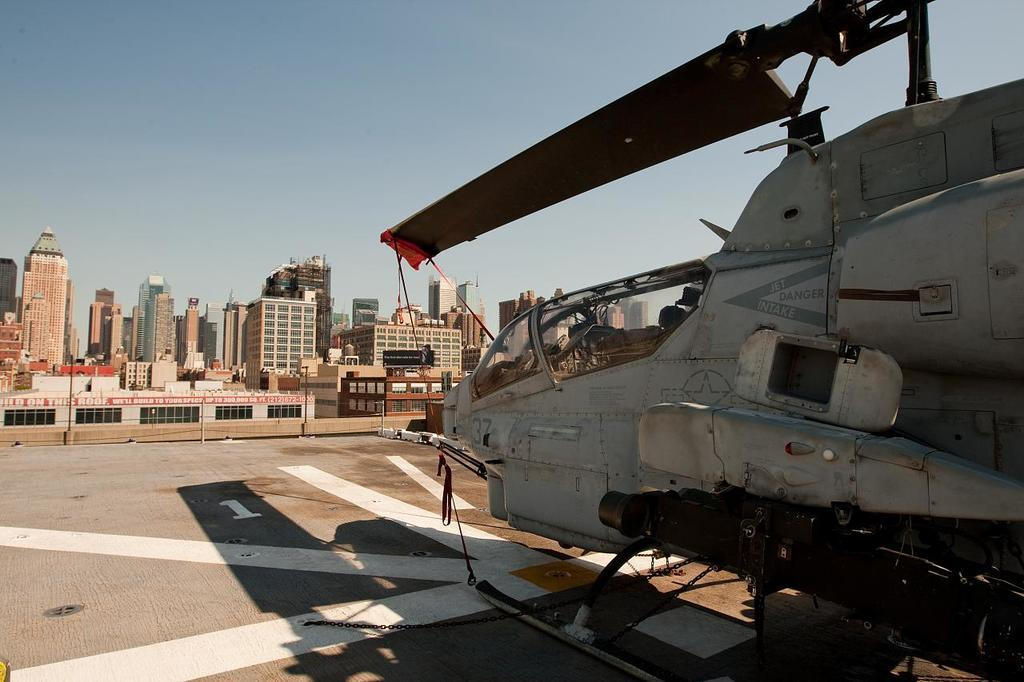What is the main subject of the image? The main subject of the image is a helicopter. Where is the helicopter located in the image? The helicopter is on the land in the image. What can be seen in the background of the image? There are buildings and the sky visible in the background of the image. What type of country is depicted in the image? There is no country depicted in the image; it features a helicopter on the land with buildings and the sky in the background. What order is the helicopter following in the image? The helicopter is not following any specific order in the image; it is stationary on the land. 